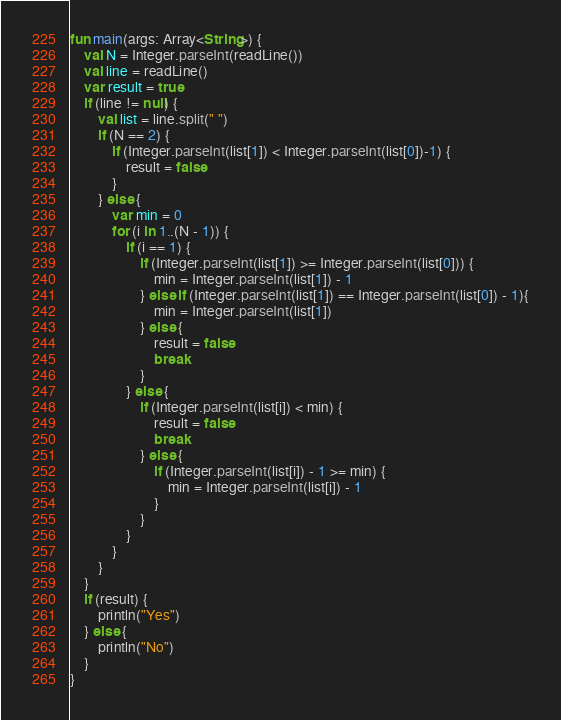<code> <loc_0><loc_0><loc_500><loc_500><_Kotlin_>fun main(args: Array<String>) {
    val N = Integer.parseInt(readLine())
    val line = readLine()
    var result = true
    if (line != null) {
        val list = line.split(" ")
        if (N == 2) {
            if (Integer.parseInt(list[1]) < Integer.parseInt(list[0])-1) {
                result = false
            }
        } else {
            var min = 0
            for (i in 1..(N - 1)) {
                if (i == 1) {
                    if (Integer.parseInt(list[1]) >= Integer.parseInt(list[0])) {
                        min = Integer.parseInt(list[1]) - 1
                    } else if (Integer.parseInt(list[1]) == Integer.parseInt(list[0]) - 1){
                        min = Integer.parseInt(list[1])
                    } else {
                        result = false
                        break
                    }
                } else {
                    if (Integer.parseInt(list[i]) < min) {
                        result = false
                        break
                    } else {
                        if (Integer.parseInt(list[i]) - 1 >= min) {
                            min = Integer.parseInt(list[i]) - 1
                        }
                    }
                }
            }
        }
    }
    if (result) {
        println("Yes")
    } else {
        println("No")
    }
}</code> 